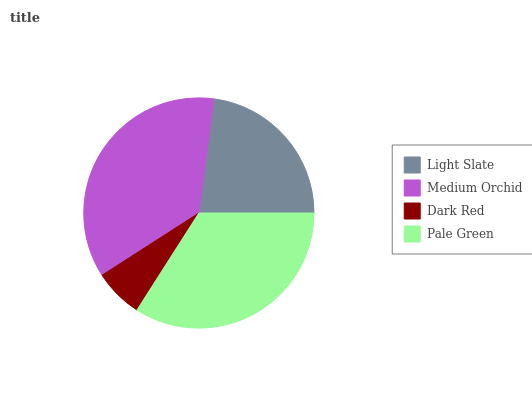Is Dark Red the minimum?
Answer yes or no. Yes. Is Medium Orchid the maximum?
Answer yes or no. Yes. Is Medium Orchid the minimum?
Answer yes or no. No. Is Dark Red the maximum?
Answer yes or no. No. Is Medium Orchid greater than Dark Red?
Answer yes or no. Yes. Is Dark Red less than Medium Orchid?
Answer yes or no. Yes. Is Dark Red greater than Medium Orchid?
Answer yes or no. No. Is Medium Orchid less than Dark Red?
Answer yes or no. No. Is Pale Green the high median?
Answer yes or no. Yes. Is Light Slate the low median?
Answer yes or no. Yes. Is Light Slate the high median?
Answer yes or no. No. Is Medium Orchid the low median?
Answer yes or no. No. 